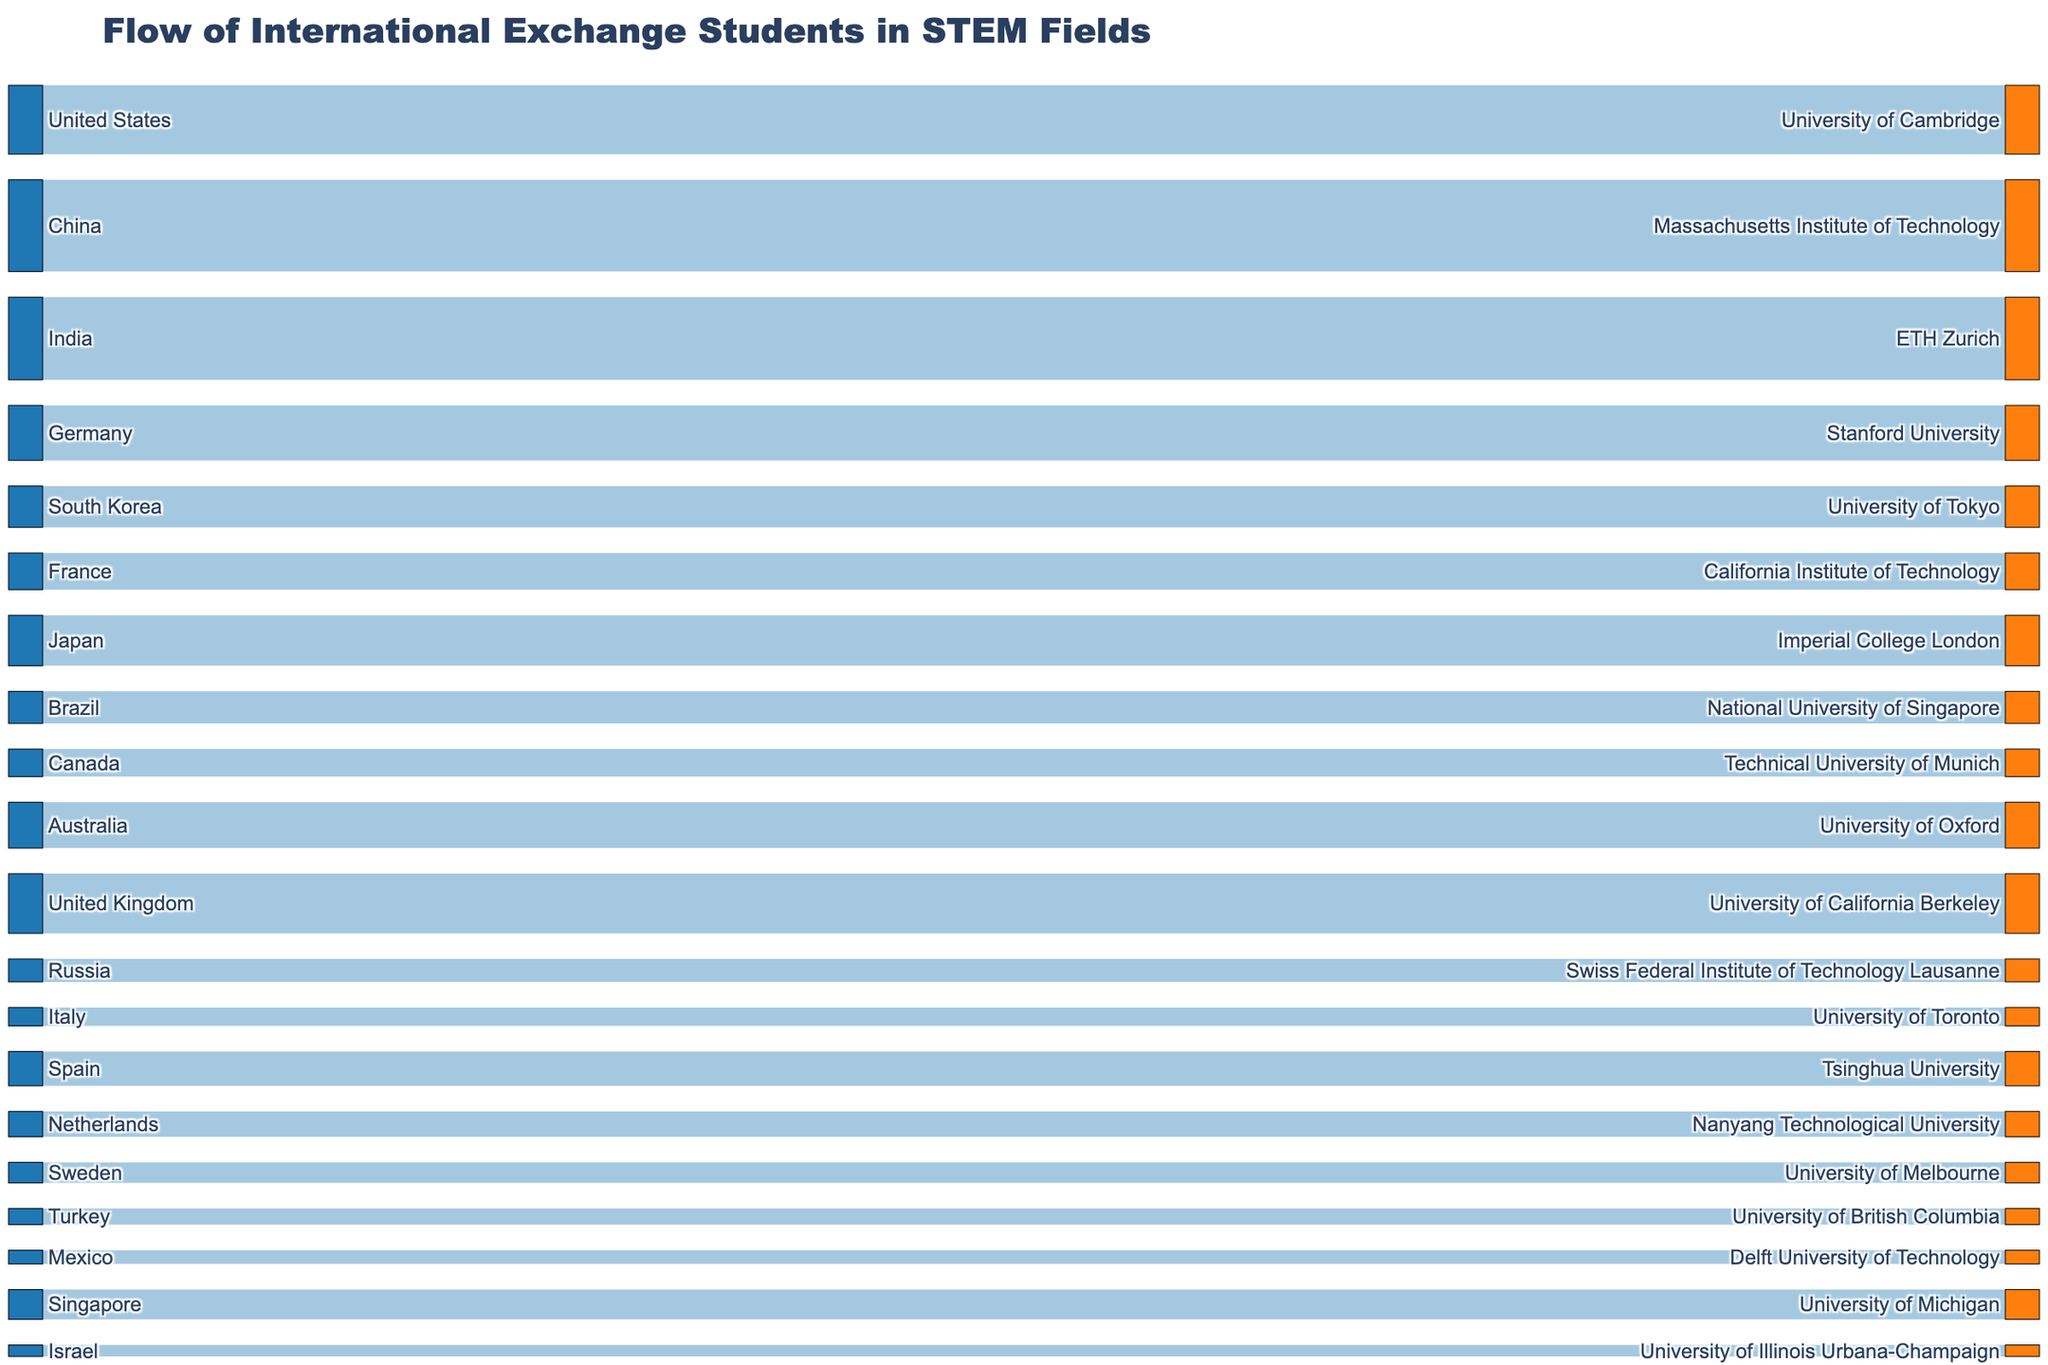what is the title of the figure? The title of the figure is typically found at the top of the chart and provides a summary of what the chart is about.
Answer: Flow of International Exchange Students in STEM Fields How many countries are listed as sources in the Sankey diagram? The number of sources corresponds to the number of unique countries on the left side of the Sankey diagram.
Answer: 20 Which host institution has the highest number of students from China? By following the flow starting from China, we can see that the target associated with the largest flow from China is the relevant institution.
Answer: Massachusetts Institute of Technology How many students in total are represented in the Sankey diagram? Sum up all the values provided for each flow from a source to a target. The totals are 150 + 200 + 180 + 120 + 90 + 80 + 110 + 70 + 60 + 100 + 130 + 50 + 40 + 75 + 55 + 45 + 35 + 30 + 65 + 25. Add these together: 1670.
Answer: 1670 Which country sends the fewest number of students to a host institution, and how many does it send? Look for the smallest value in the 'value' column tied to a country, which indicates the fewest students sent to a host institution.
Answer: Israel, 25 Which host institution receives the highest number of students overall? Sum the values of all flows leading to each host institution and identify the institution with the highest total.
Answer: Massachusetts Institute of Technology How does the number of students from Australia compare to those from the United Kingdom? Compare the respective values for flows originating from Australia and the United Kingdom to determine which is higher.
Answer: United Kingdom has more, 130 compared to Australia's 100 What is the average number of students sent by the countries to their respective host institutions? Sum the total number of students and divide it by the number of countries. Total students are 1670 and there are 20 countries. Therefore, 1670 / 20 = 83.5.
Answer: 83.5 What is the total number of students studying in universities located in the United States? Identify flows leading to universities in the United States (Massachusetts Institute of Technology, Stanford University, California Institute of Technology, University of California Berkeley, University of Michigan, University of Illinois Urbana-Champaign). Sum these values: 200 + 120 + 80 + 130 + 65 + 25 = 620.
Answer: 620 